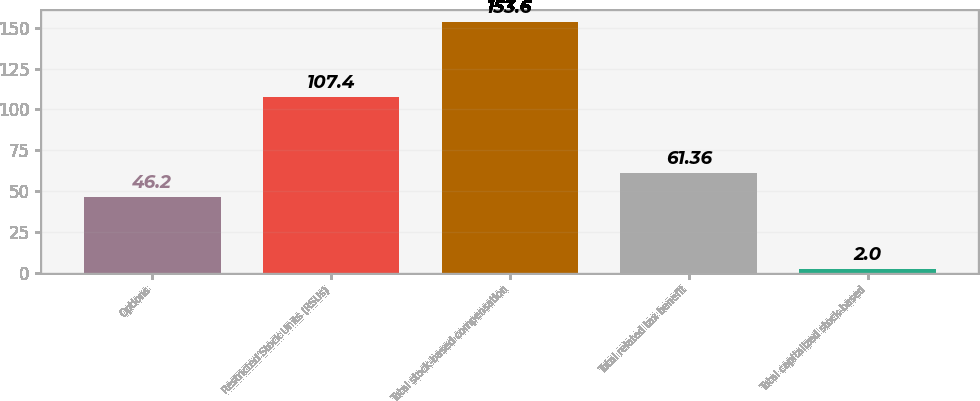<chart> <loc_0><loc_0><loc_500><loc_500><bar_chart><fcel>Options<fcel>Restricted Stock Units (RSUs)<fcel>Total stock-based compensation<fcel>Total related tax benefit<fcel>Total capitalized stock-based<nl><fcel>46.2<fcel>107.4<fcel>153.6<fcel>61.36<fcel>2<nl></chart> 